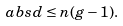Convert formula to latex. <formula><loc_0><loc_0><loc_500><loc_500>\ a b s { d } \leq n ( g - 1 ) .</formula> 